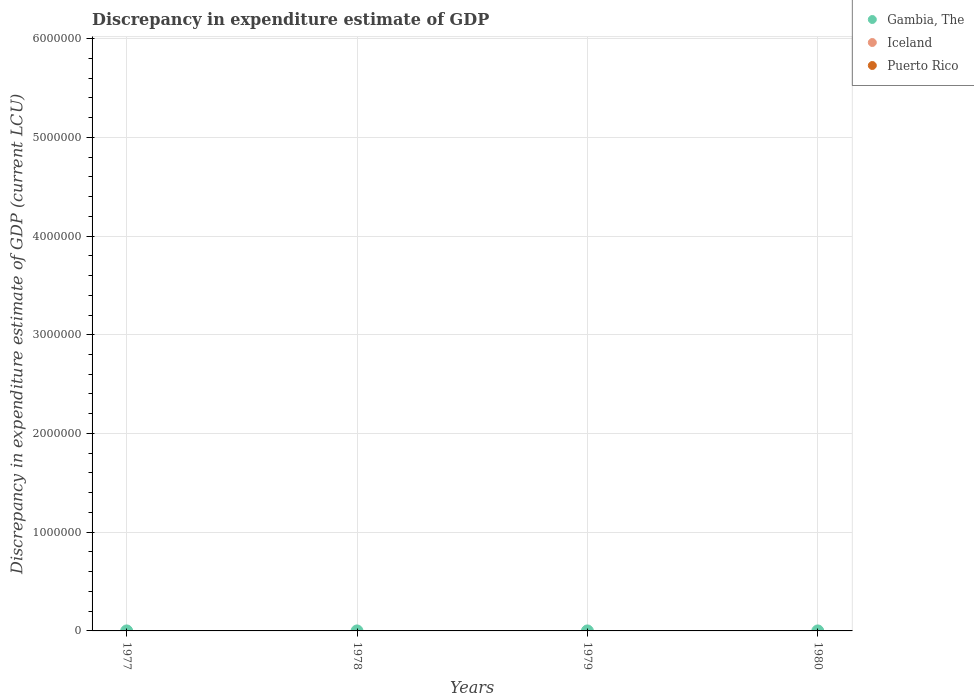How many different coloured dotlines are there?
Offer a terse response. 1. What is the discrepancy in expenditure estimate of GDP in Iceland in 1979?
Make the answer very short. 0. Across all years, what is the maximum discrepancy in expenditure estimate of GDP in Gambia, The?
Ensure brevity in your answer.  7e-8. What is the total discrepancy in expenditure estimate of GDP in Iceland in the graph?
Keep it short and to the point. 0. What is the difference between the discrepancy in expenditure estimate of GDP in Gambia, The in 1978 and the discrepancy in expenditure estimate of GDP in Puerto Rico in 1980?
Make the answer very short. 0. What is the average discrepancy in expenditure estimate of GDP in Gambia, The per year?
Keep it short and to the point. 1.75e-8. What is the difference between the highest and the lowest discrepancy in expenditure estimate of GDP in Gambia, The?
Give a very brief answer. 7e-8. In how many years, is the discrepancy in expenditure estimate of GDP in Iceland greater than the average discrepancy in expenditure estimate of GDP in Iceland taken over all years?
Provide a succinct answer. 0. Is it the case that in every year, the sum of the discrepancy in expenditure estimate of GDP in Puerto Rico and discrepancy in expenditure estimate of GDP in Iceland  is greater than the discrepancy in expenditure estimate of GDP in Gambia, The?
Offer a terse response. No. How many dotlines are there?
Make the answer very short. 1. What is the difference between two consecutive major ticks on the Y-axis?
Ensure brevity in your answer.  1.00e+06. Does the graph contain any zero values?
Offer a terse response. Yes. Where does the legend appear in the graph?
Provide a short and direct response. Top right. What is the title of the graph?
Provide a succinct answer. Discrepancy in expenditure estimate of GDP. Does "France" appear as one of the legend labels in the graph?
Your response must be concise. No. What is the label or title of the Y-axis?
Your answer should be very brief. Discrepancy in expenditure estimate of GDP (current LCU). What is the Discrepancy in expenditure estimate of GDP (current LCU) in Gambia, The in 1977?
Provide a short and direct response. 7e-8. What is the Discrepancy in expenditure estimate of GDP (current LCU) of Iceland in 1977?
Provide a succinct answer. 0. What is the Discrepancy in expenditure estimate of GDP (current LCU) of Puerto Rico in 1977?
Keep it short and to the point. 0. What is the Discrepancy in expenditure estimate of GDP (current LCU) of Iceland in 1978?
Make the answer very short. 0. What is the Discrepancy in expenditure estimate of GDP (current LCU) of Puerto Rico in 1978?
Keep it short and to the point. 0. What is the Discrepancy in expenditure estimate of GDP (current LCU) in Iceland in 1979?
Your response must be concise. 0. What is the Discrepancy in expenditure estimate of GDP (current LCU) of Puerto Rico in 1979?
Provide a short and direct response. 0. What is the Discrepancy in expenditure estimate of GDP (current LCU) of Gambia, The in 1980?
Your response must be concise. 0. Across all years, what is the maximum Discrepancy in expenditure estimate of GDP (current LCU) of Gambia, The?
Ensure brevity in your answer.  7e-8. What is the total Discrepancy in expenditure estimate of GDP (current LCU) of Gambia, The in the graph?
Keep it short and to the point. 0. What is the average Discrepancy in expenditure estimate of GDP (current LCU) in Gambia, The per year?
Provide a succinct answer. 0. What is the average Discrepancy in expenditure estimate of GDP (current LCU) in Iceland per year?
Your answer should be compact. 0. What is the difference between the highest and the lowest Discrepancy in expenditure estimate of GDP (current LCU) of Gambia, The?
Your answer should be compact. 0. 